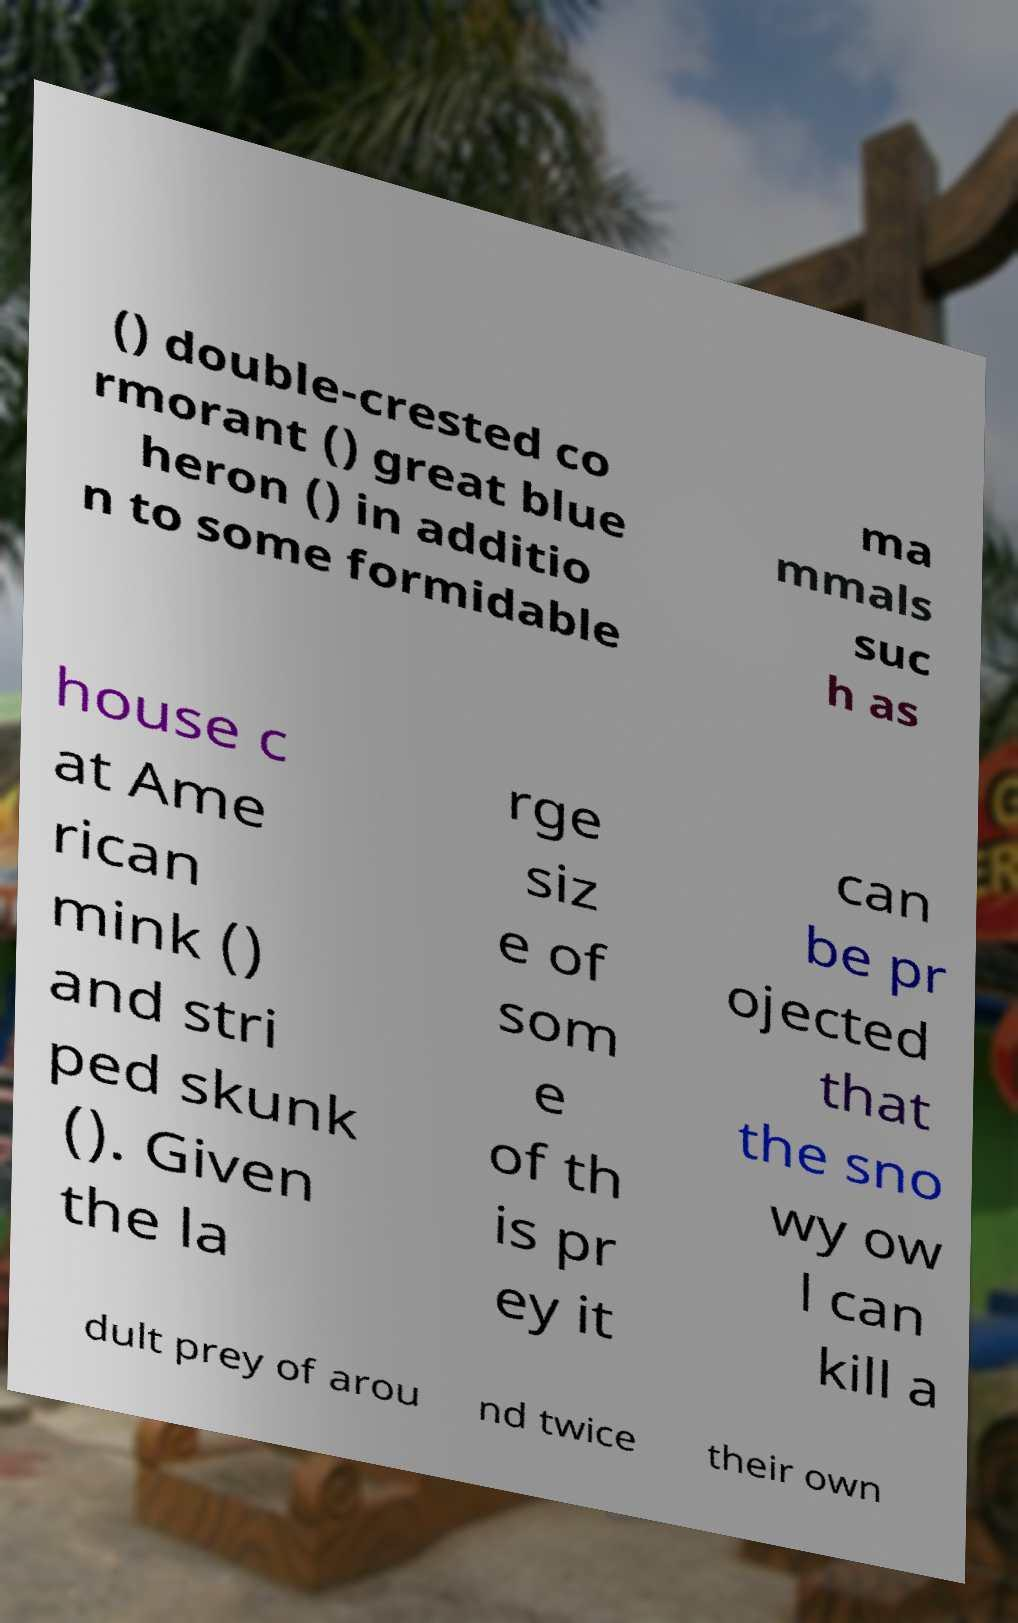I need the written content from this picture converted into text. Can you do that? () double-crested co rmorant () great blue heron () in additio n to some formidable ma mmals suc h as house c at Ame rican mink () and stri ped skunk (). Given the la rge siz e of som e of th is pr ey it can be pr ojected that the sno wy ow l can kill a dult prey of arou nd twice their own 